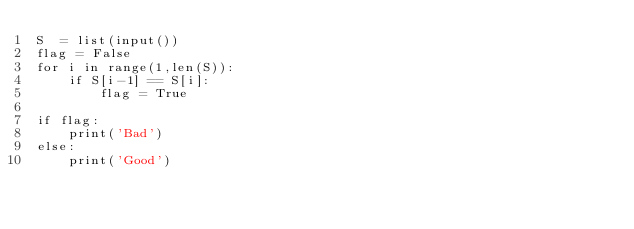<code> <loc_0><loc_0><loc_500><loc_500><_Python_>S  = list(input())
flag = False
for i in range(1,len(S)):
    if S[i-1] == S[i]:
        flag = True
        
if flag:
    print('Bad')
else:
    print('Good')</code> 